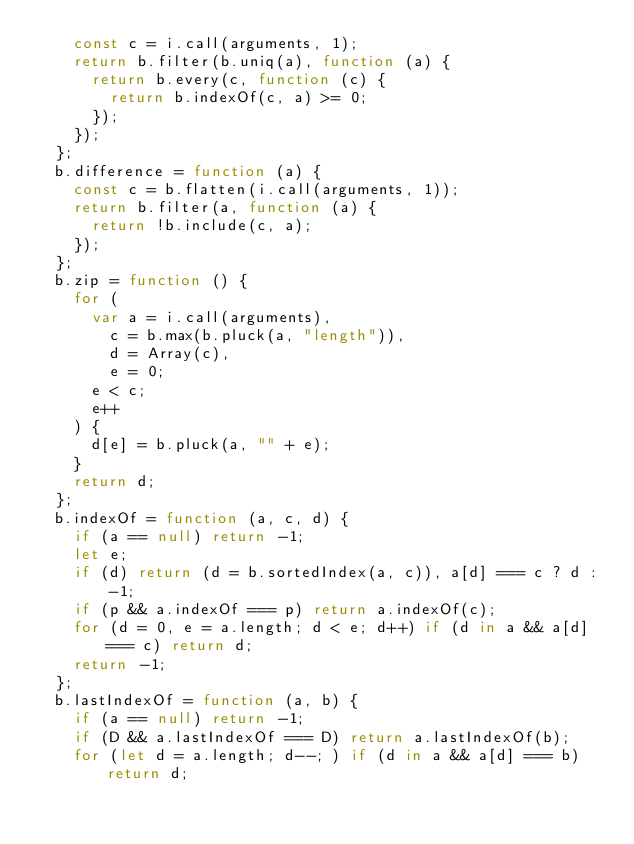Convert code to text. <code><loc_0><loc_0><loc_500><loc_500><_JavaScript_>    const c = i.call(arguments, 1);
    return b.filter(b.uniq(a), function (a) {
      return b.every(c, function (c) {
        return b.indexOf(c, a) >= 0;
      });
    });
  };
  b.difference = function (a) {
    const c = b.flatten(i.call(arguments, 1));
    return b.filter(a, function (a) {
      return !b.include(c, a);
    });
  };
  b.zip = function () {
    for (
      var a = i.call(arguments),
        c = b.max(b.pluck(a, "length")),
        d = Array(c),
        e = 0;
      e < c;
      e++
    ) {
      d[e] = b.pluck(a, "" + e);
    }
    return d;
  };
  b.indexOf = function (a, c, d) {
    if (a == null) return -1;
    let e;
    if (d) return (d = b.sortedIndex(a, c)), a[d] === c ? d : -1;
    if (p && a.indexOf === p) return a.indexOf(c);
    for (d = 0, e = a.length; d < e; d++) if (d in a && a[d] === c) return d;
    return -1;
  };
  b.lastIndexOf = function (a, b) {
    if (a == null) return -1;
    if (D && a.lastIndexOf === D) return a.lastIndexOf(b);
    for (let d = a.length; d--; ) if (d in a && a[d] === b) return d;</code> 